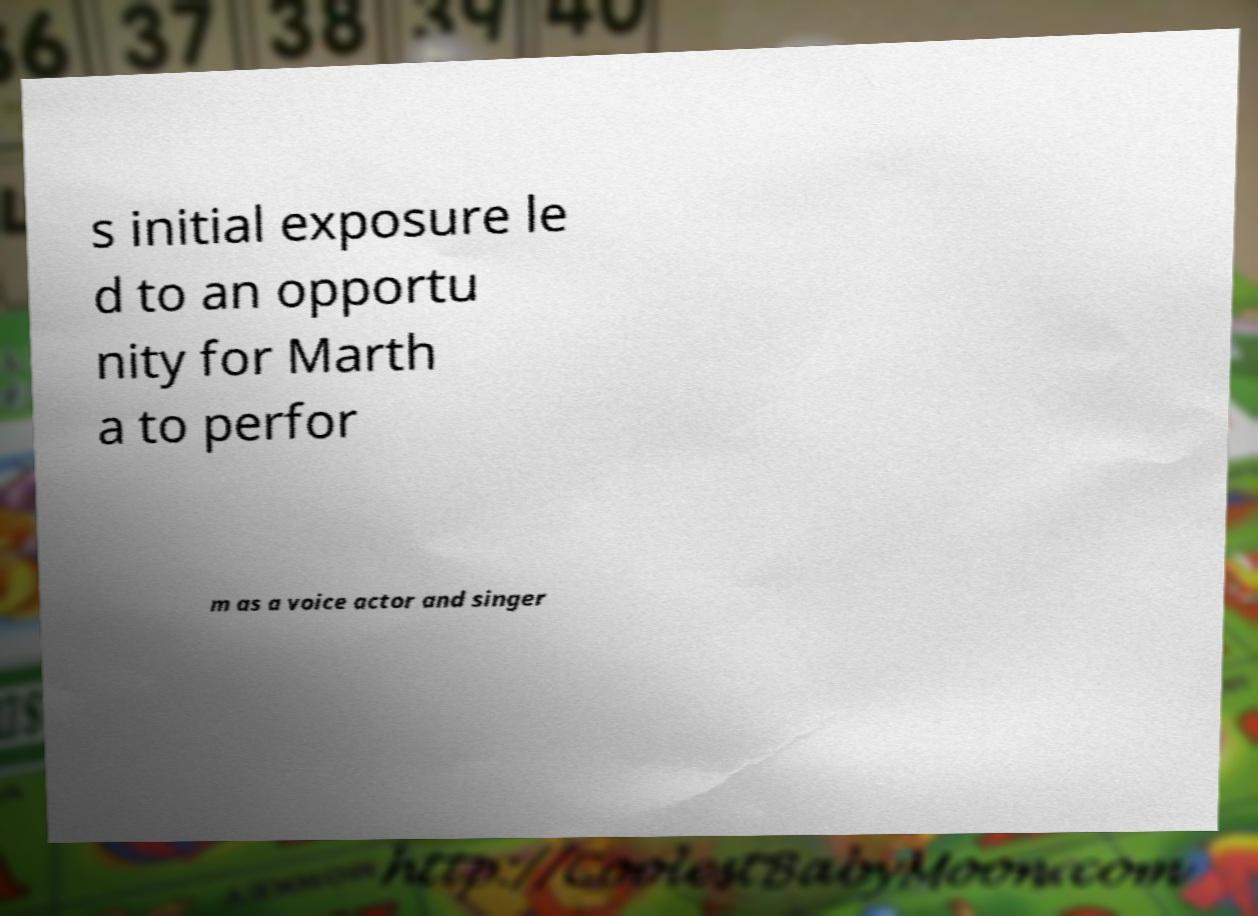Can you read and provide the text displayed in the image?This photo seems to have some interesting text. Can you extract and type it out for me? s initial exposure le d to an opportu nity for Marth a to perfor m as a voice actor and singer 